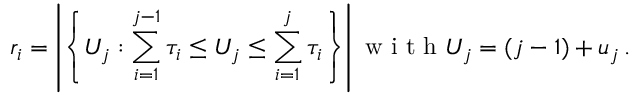Convert formula to latex. <formula><loc_0><loc_0><loc_500><loc_500>r _ { i } = \left | \left \{ U _ { j } \colon \sum _ { i = 1 } ^ { j - 1 } \tau _ { i } \leq U _ { j } \leq \sum _ { i = 1 } ^ { j } \tau _ { i } \right \} \right | w i t h U _ { j } = ( j - 1 ) + u _ { j } \, .</formula> 